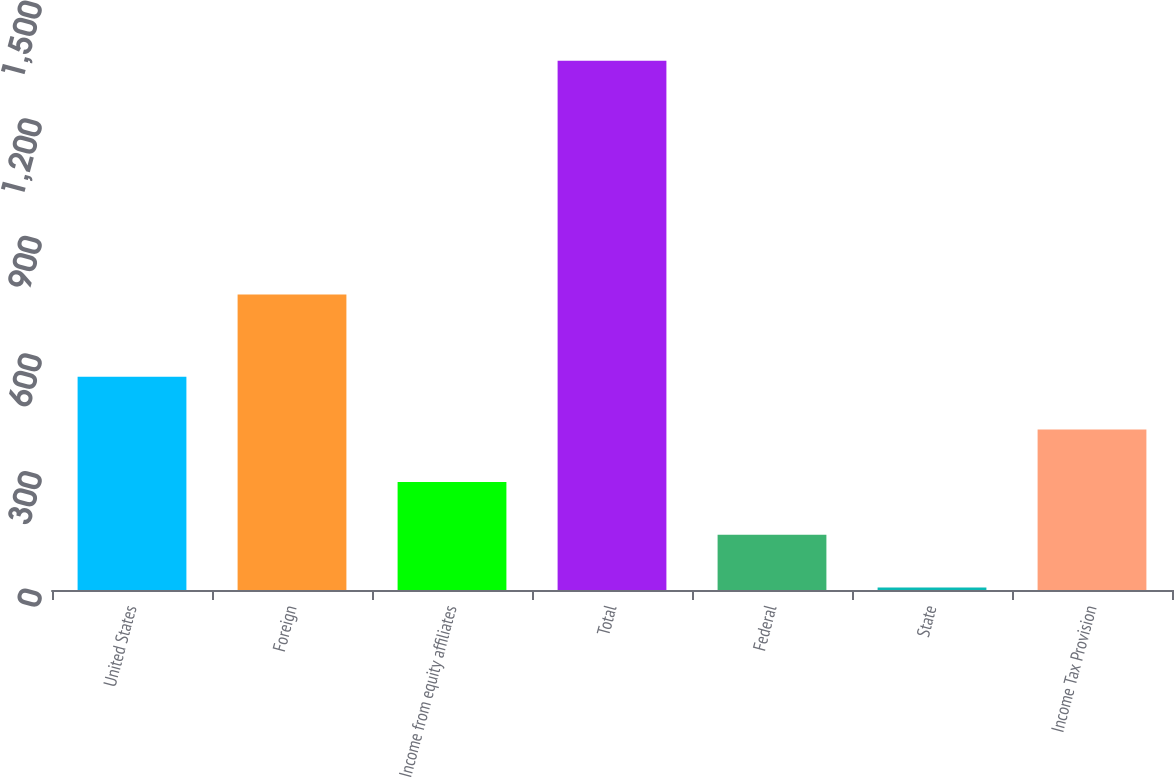Convert chart to OTSL. <chart><loc_0><loc_0><loc_500><loc_500><bar_chart><fcel>United States<fcel>Foreign<fcel>Income from equity affiliates<fcel>Total<fcel>Federal<fcel>State<fcel>Income Tax Provision<nl><fcel>544.06<fcel>754.1<fcel>275.28<fcel>1350.4<fcel>140.89<fcel>6.5<fcel>409.67<nl></chart> 